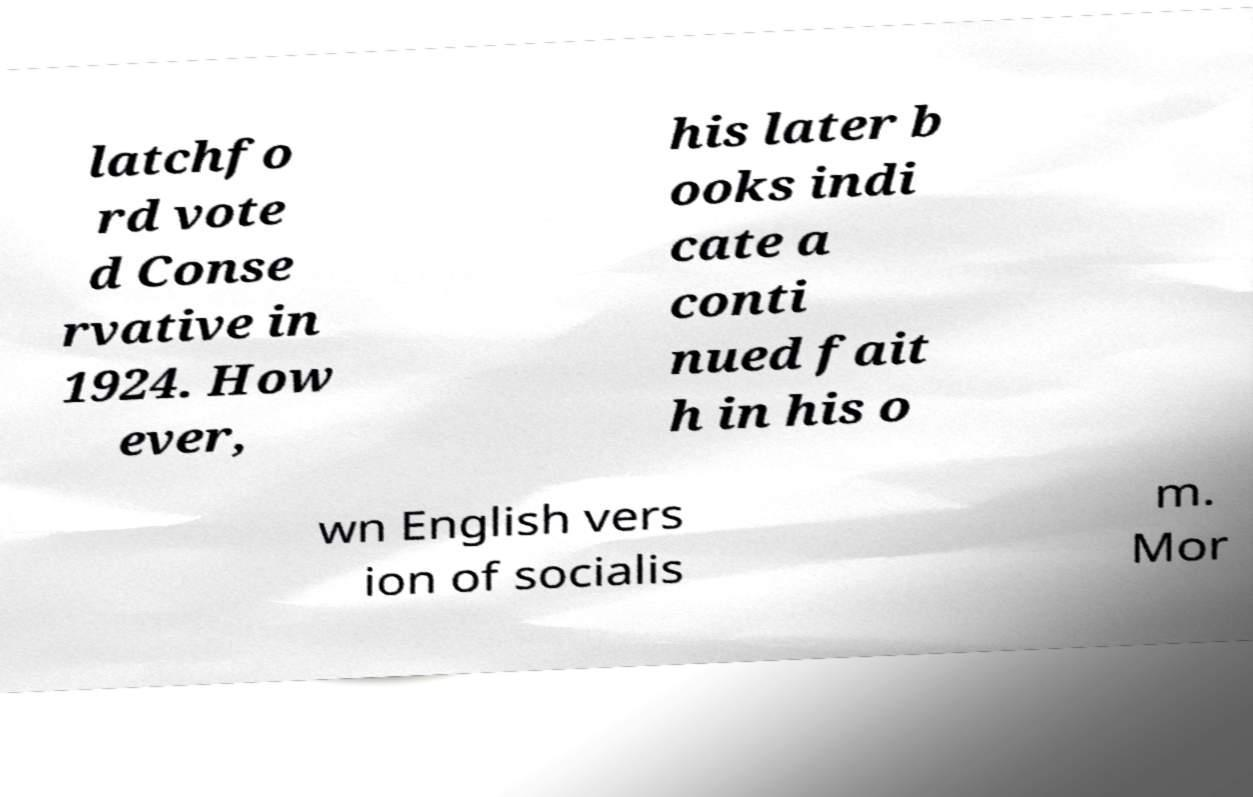Could you extract and type out the text from this image? latchfo rd vote d Conse rvative in 1924. How ever, his later b ooks indi cate a conti nued fait h in his o wn English vers ion of socialis m. Mor 